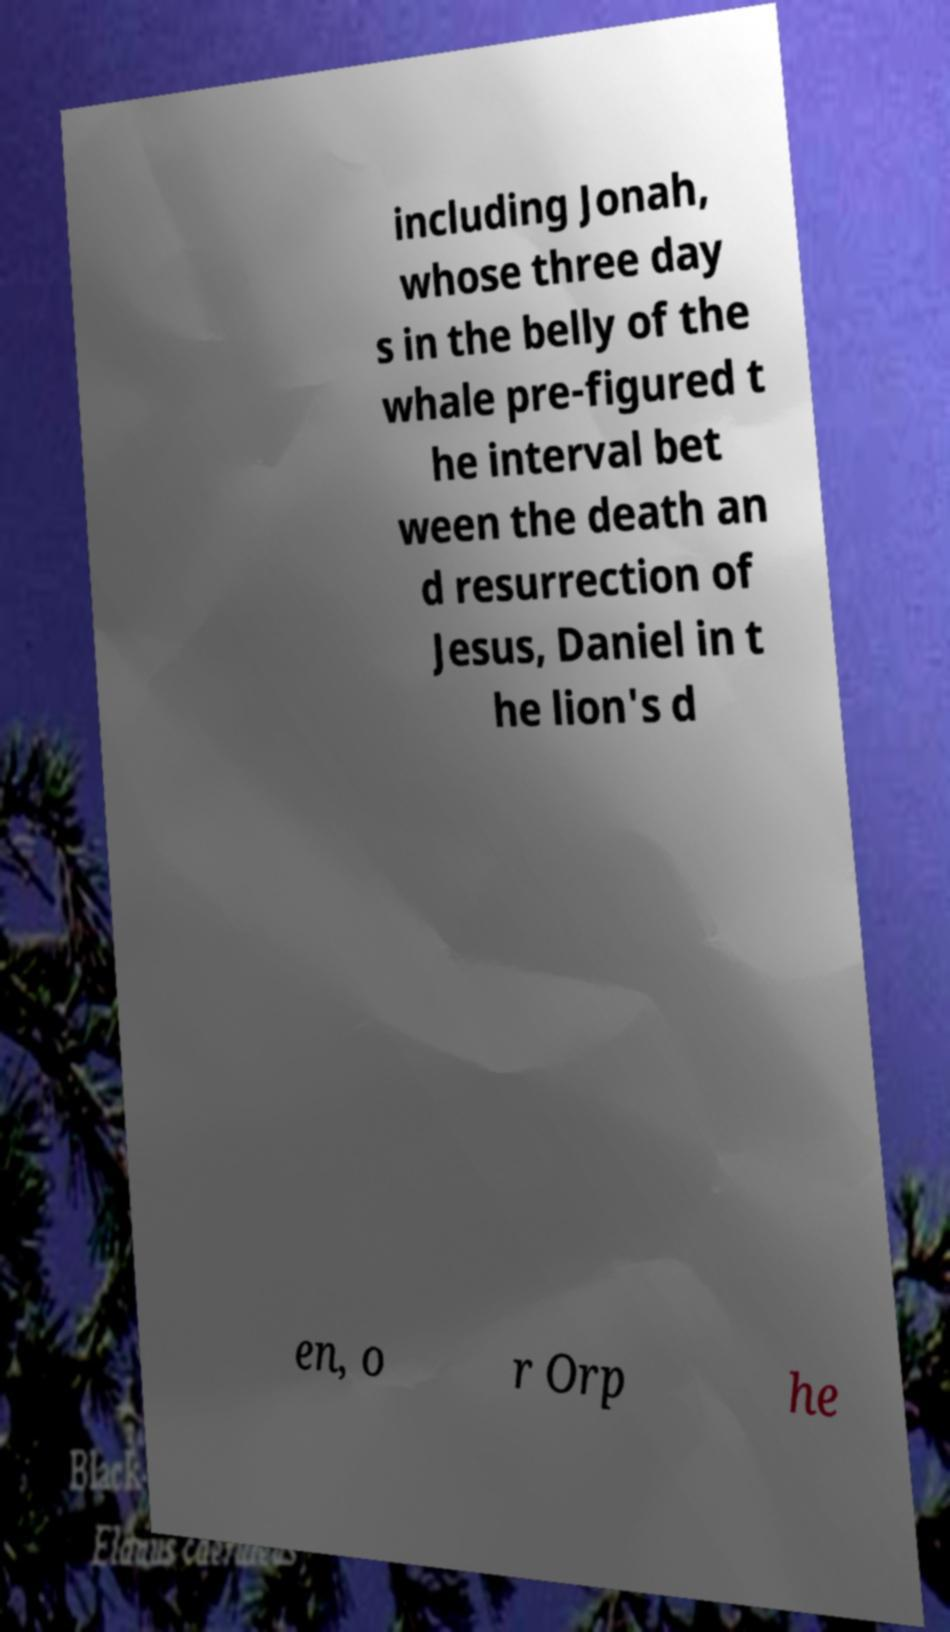What messages or text are displayed in this image? I need them in a readable, typed format. including Jonah, whose three day s in the belly of the whale pre-figured t he interval bet ween the death an d resurrection of Jesus, Daniel in t he lion's d en, o r Orp he 